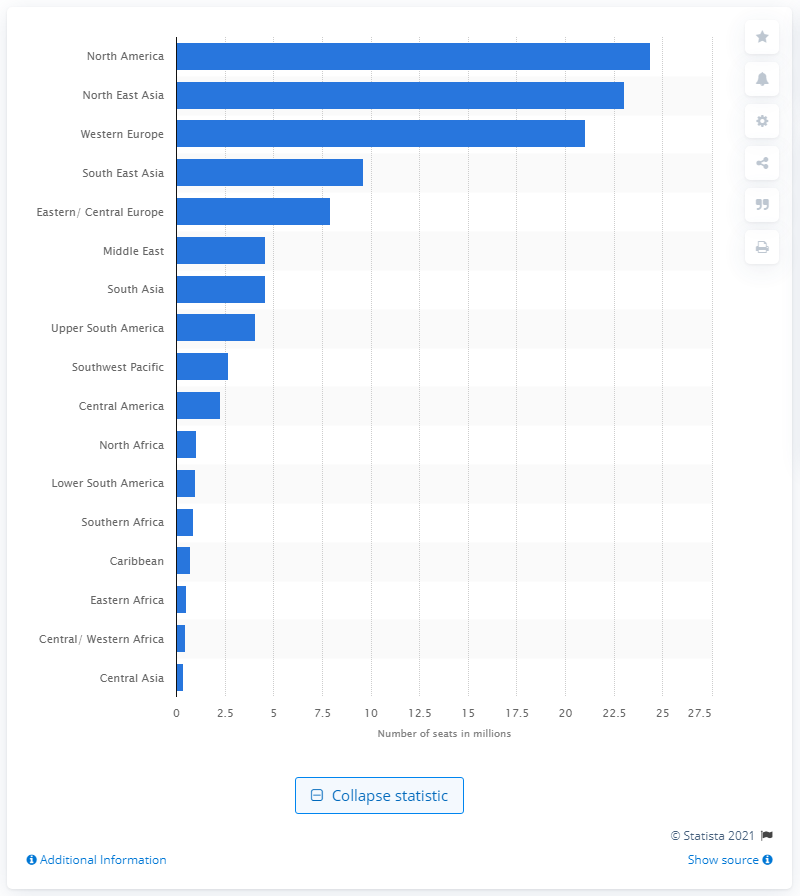Highlight a few significant elements in this photo. In the week of May 6, 2019, the airline industry in North America had a total of 24,360 seats available for use. 